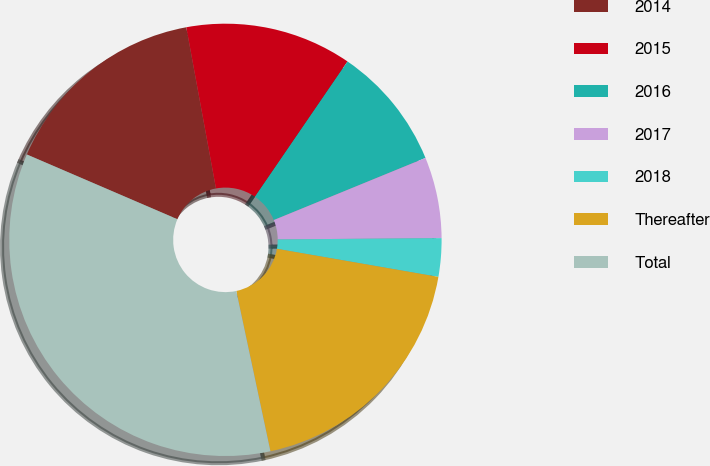<chart> <loc_0><loc_0><loc_500><loc_500><pie_chart><fcel>2014<fcel>2015<fcel>2016<fcel>2017<fcel>2018<fcel>Thereafter<fcel>Total<nl><fcel>15.64%<fcel>12.45%<fcel>9.26%<fcel>6.06%<fcel>2.87%<fcel>18.92%<fcel>34.8%<nl></chart> 